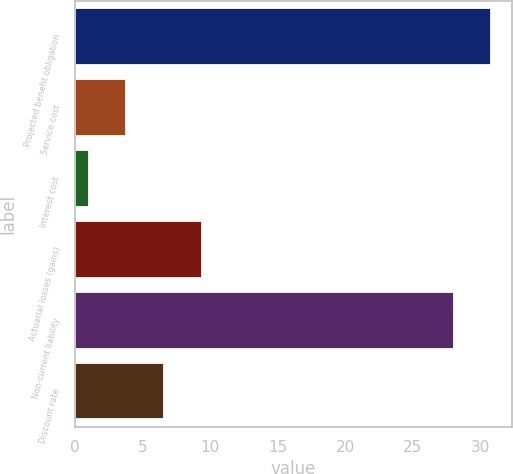Convert chart. <chart><loc_0><loc_0><loc_500><loc_500><bar_chart><fcel>Projected benefit obligation<fcel>Service cost<fcel>Interest cost<fcel>Actuarial losses (gains)<fcel>Non-current liability<fcel>Discount rate<nl><fcel>30.8<fcel>3.8<fcel>1<fcel>9.4<fcel>28<fcel>6.6<nl></chart> 